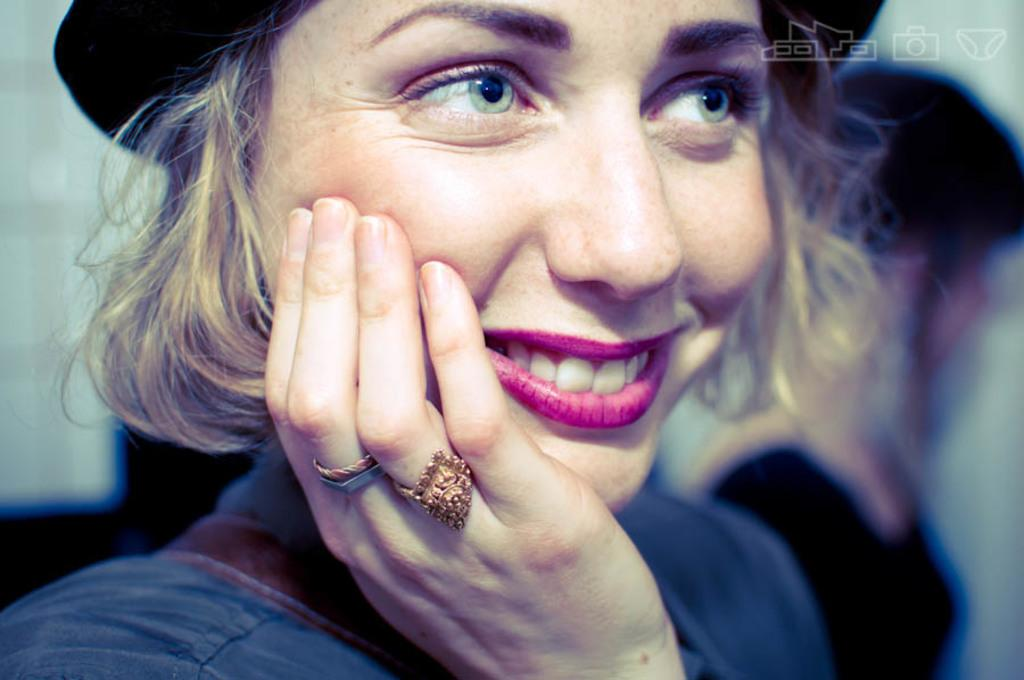How many people are in the image? There are two persons in the image. What is the woman wearing on her head? One woman is wearing a hat. What type of jewelry can be seen on the woman's fingers? The woman has rings on her fingers. Where are the logos located in the image? The logos are in the top right corner of the image. What type of fish can be seen swimming in the woman's hat? There is no fish present in the image, and the woman's hat does not contain any water for a fish to swim in. 